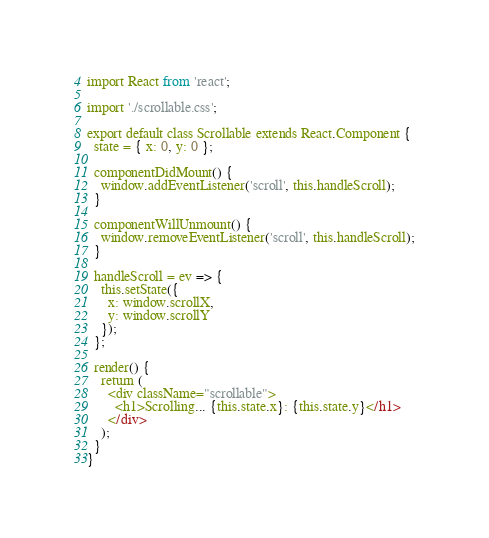<code> <loc_0><loc_0><loc_500><loc_500><_JavaScript_>import React from 'react';

import './scrollable.css';

export default class Scrollable extends React.Component {
  state = { x: 0, y: 0 };

  componentDidMount() {
    window.addEventListener('scroll', this.handleScroll);
  }

  componentWillUnmount() {
    window.removeEventListener('scroll', this.handleScroll);
  }

  handleScroll = ev => {
    this.setState({
      x: window.scrollX,
      y: window.scrollY
    });
  };

  render() {
    return (
      <div className="scrollable">
        <h1>Scrolling... {this.state.x}: {this.state.y}</h1>
      </div>
    );
  }
}</code> 